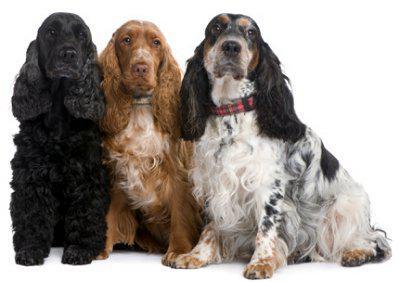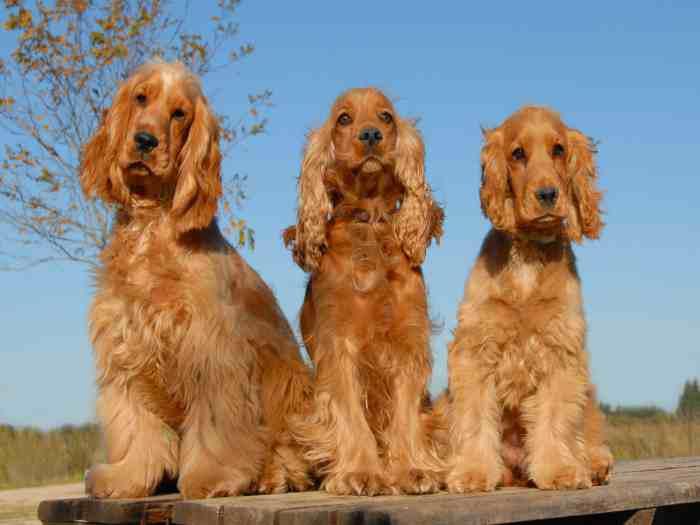The first image is the image on the left, the second image is the image on the right. Analyze the images presented: Is the assertion "There are at least four dogs." valid? Answer yes or no. Yes. 